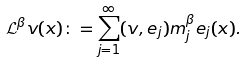<formula> <loc_0><loc_0><loc_500><loc_500>\mathcal { L } ^ { \beta } v ( x ) \colon = \sum _ { j = 1 } ^ { \infty } ( v , e _ { j } ) m _ { j } ^ { \beta } e _ { j } ( x ) .</formula> 